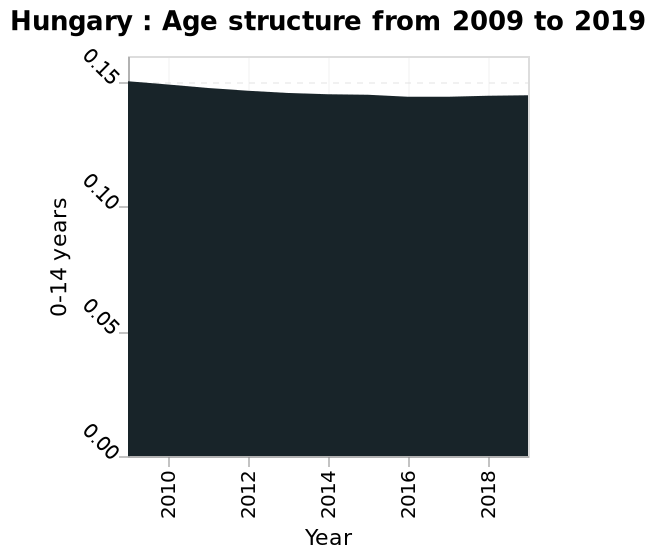<image>
Offer a thorough analysis of the image. From 2010 to 2018 there was a slight decrease in the number of 0-14 year olds in Hungary. What is the maximum year represented on the plot? The maximum year represented on the plot is 2019. What age group in Hungary saw a decrease in numbers between 2010 and 2018? The age group of 0-14 year olds in Hungary saw a decrease in numbers between 2010 and 2018. 